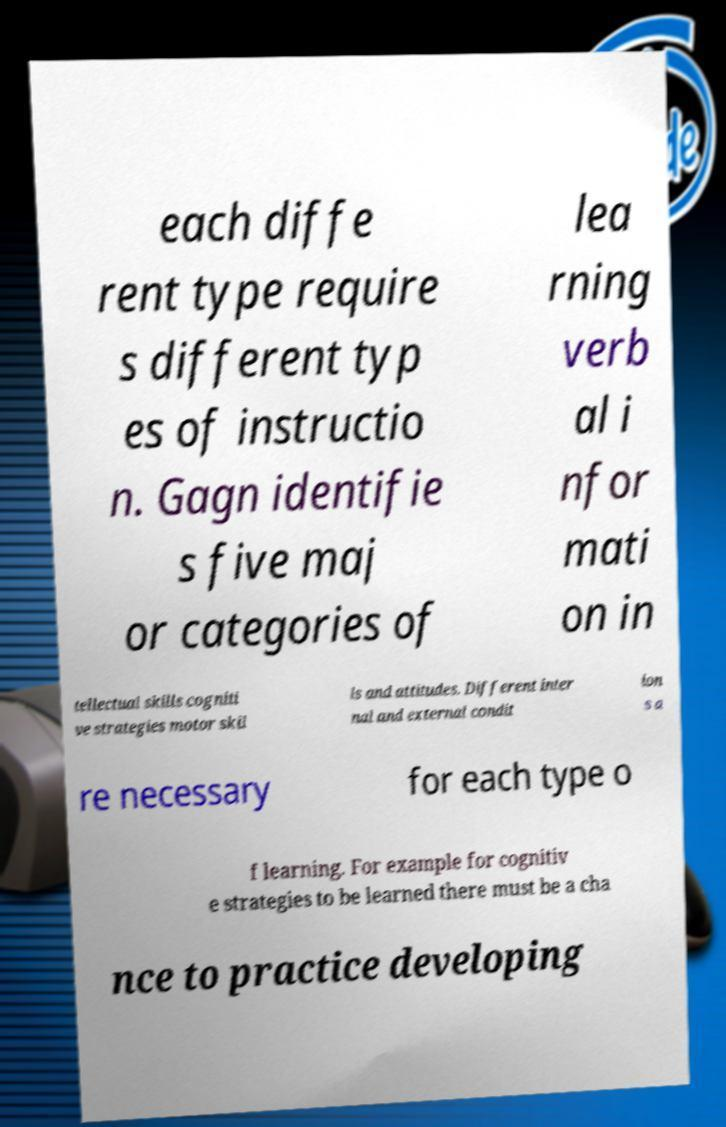I need the written content from this picture converted into text. Can you do that? each diffe rent type require s different typ es of instructio n. Gagn identifie s five maj or categories of lea rning verb al i nfor mati on in tellectual skills cogniti ve strategies motor skil ls and attitudes. Different inter nal and external condit ion s a re necessary for each type o f learning. For example for cognitiv e strategies to be learned there must be a cha nce to practice developing 